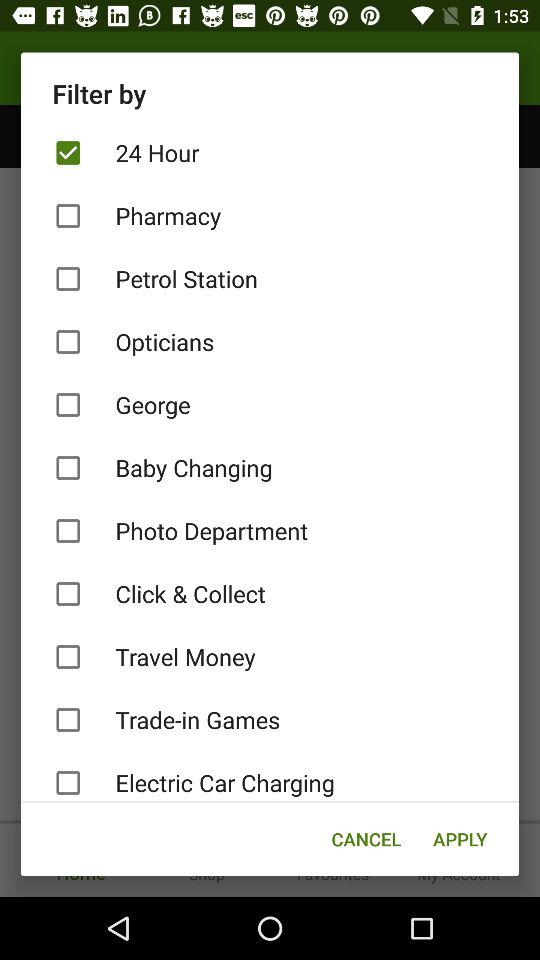What is the option selected for "Filter by"? The selected option is "24 Hour". 